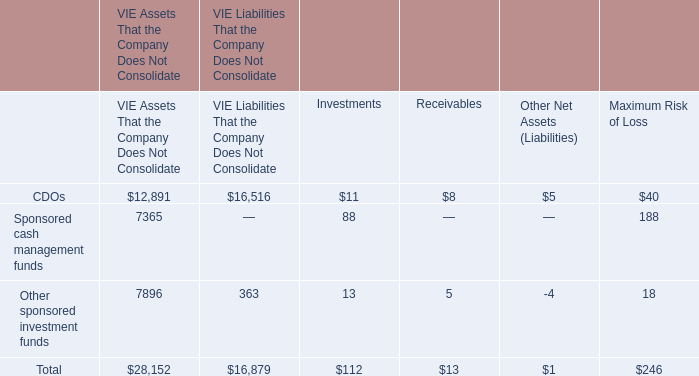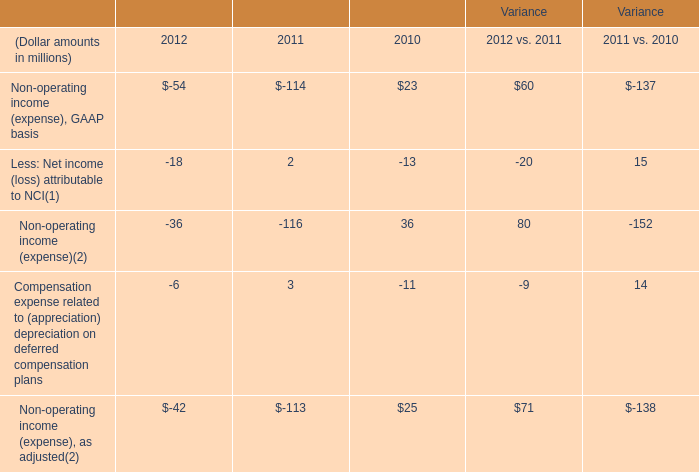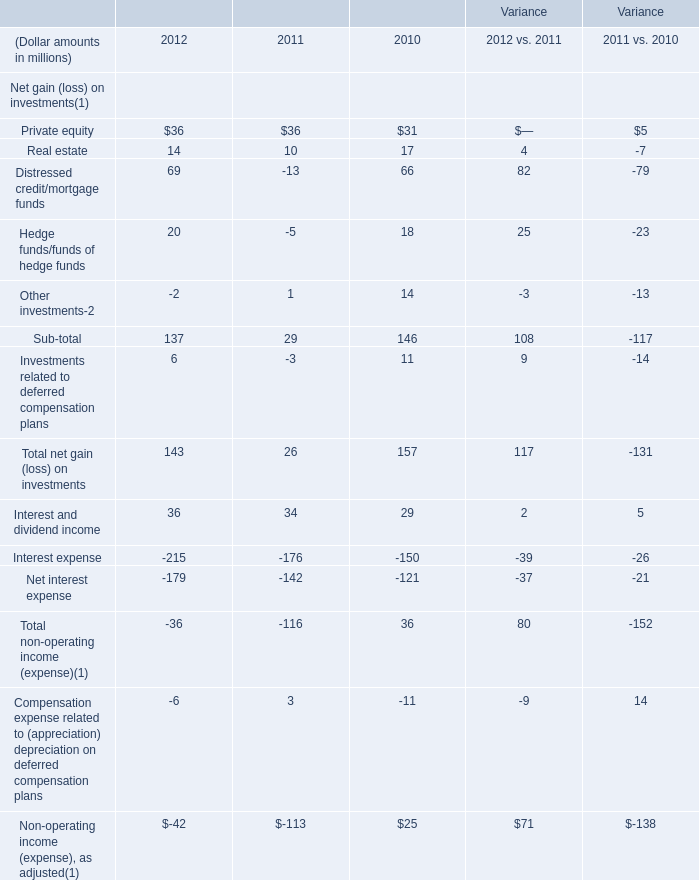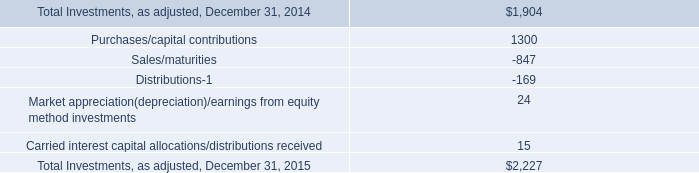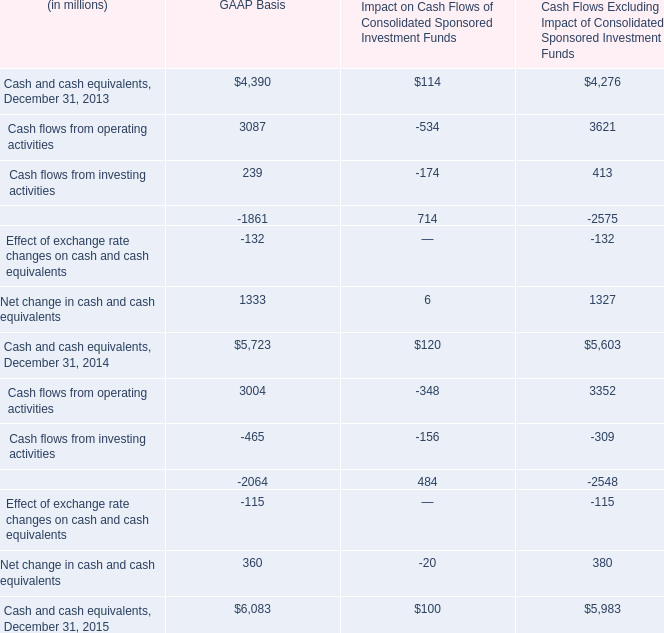What's the average of the Real estate in the years where Other investments- is positive? (in million) 
Computations: ((10 + 17) / 2)
Answer: 13.5. 